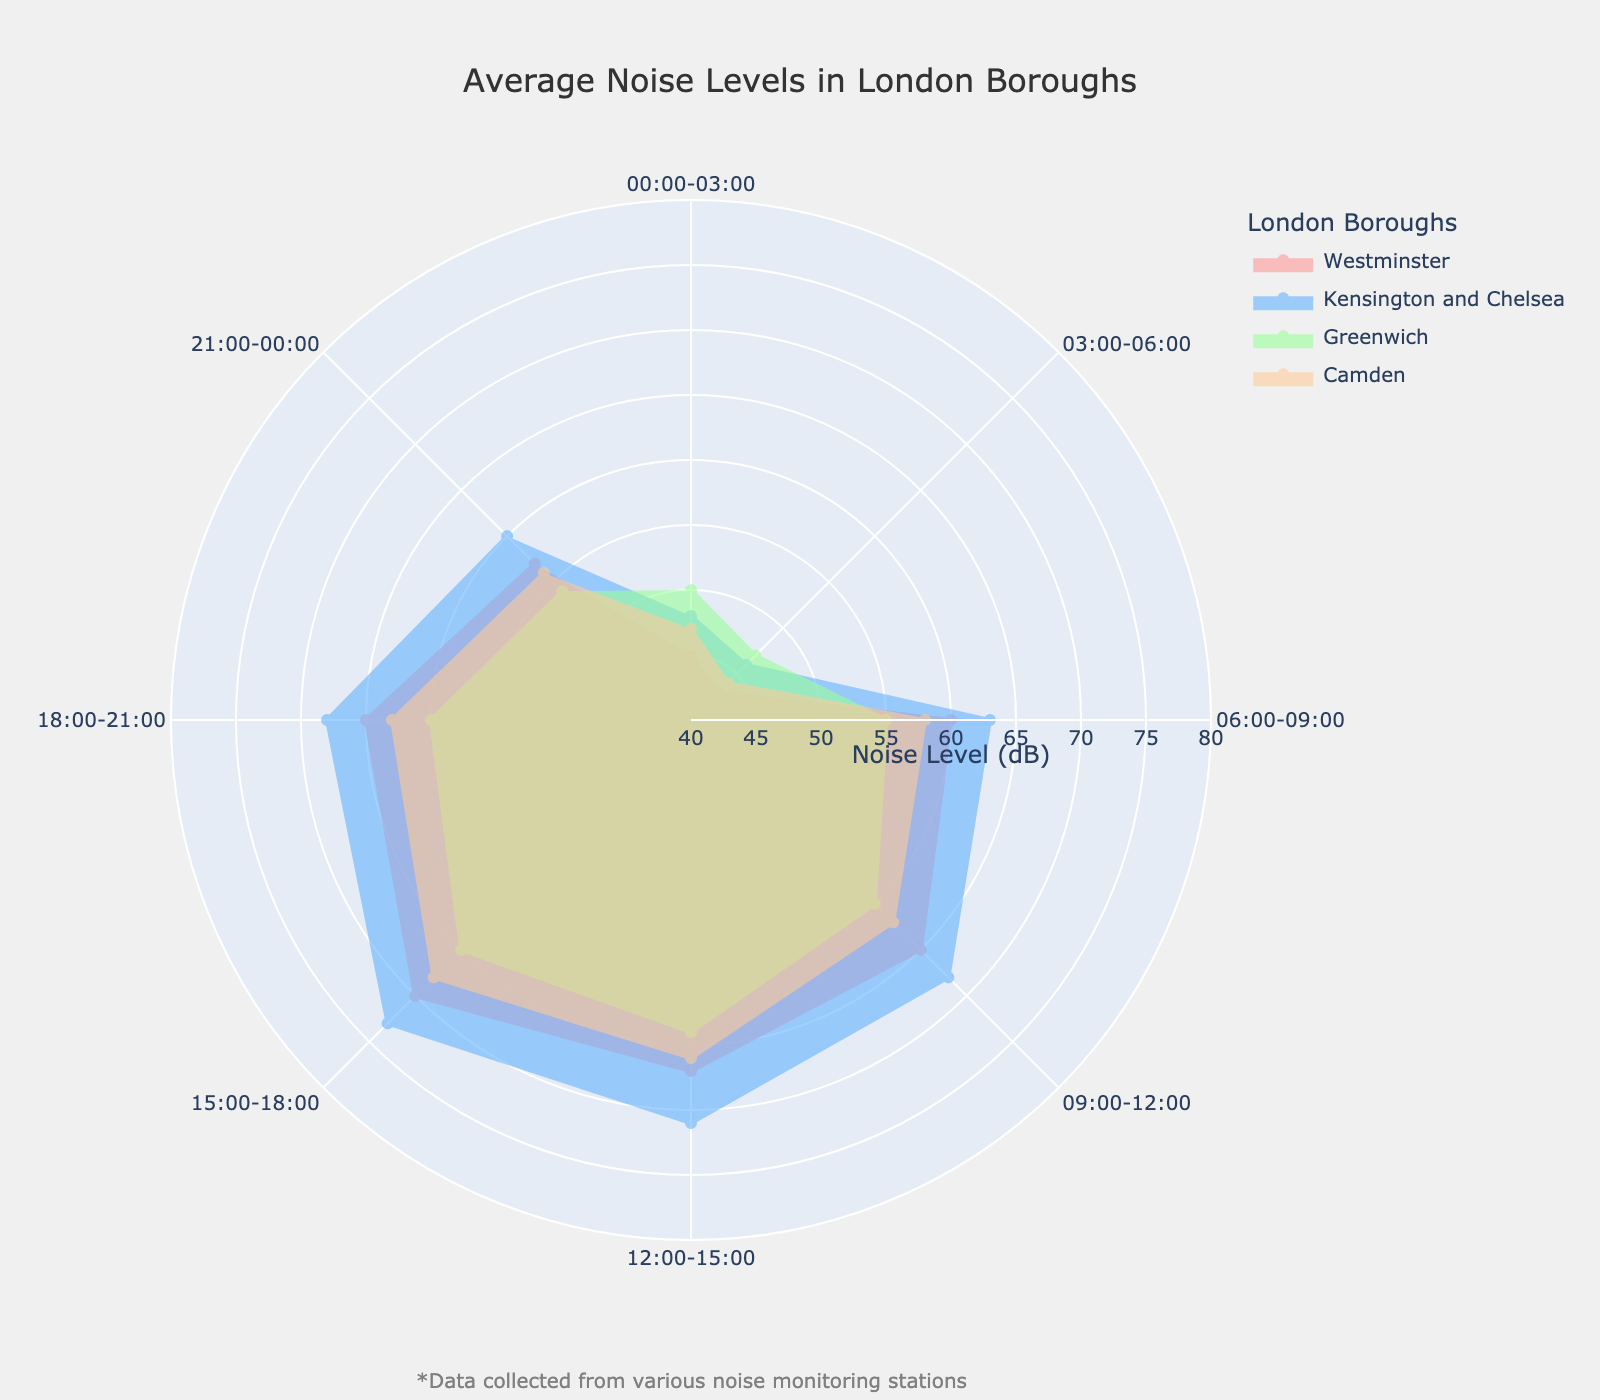what is the average noise level in Camden between 06:00 to 09:00? The figure shows the noise levels for Camden during different times. Look at the value corresponding to "06:00-09:00" under Camden, which is 58 dB.
Answer: 58 dB Which borough has the highest noise level during the 15:00-18:00 time period? The figure shows the noise levels for each borough during the different time periods. Look at the values corresponding to "15:00-18:00" for each borough: Westminster (70 dB), Kensington and Chelsea (73 dB), Greenwich (65 dB), and Camden (68 dB). Kensington and Chelsea have the highest value.
Answer: Kensington and Chelsea What is the difference in noise levels in Greenwich between 00:00-03:00 and 03:00-06:00? Look at the noise levels for Greenwich at "00:00-03:00" which is 50 dB and "03:00-06:00" which is 47 dB. The difference is 50 - 47 = 3 dB.
Answer: 3 dB During which time period does Westminster have the lowest noise level? Look at the noise levels for Westminster during different times. The values are: "00:00-03:00" (45 dB), "03:00-06:00" (43 dB), "06:00-09:00" (60 dB), "09:00-12:00" (65 dB), "12:00-15:00" (67 dB), "15:00-18:00" (70 dB), "18:00-21:00" (65 dB), and "21:00-00:00" (57 dB). The lowest value is at "03:00-06:00".
Answer: 03:00-06:00 What is the range of noise levels in Kensington and Chelsea throughout the day? Look at the noise levels for Kensington and Chelsea at different times: 48 dB (00:00-03:00), 46 dB (03:00-06:00), 63 dB (06:00-09:00), 68 dB (09:00-12:00), 71 dB (12:00-15:00), 73 dB (15:00-18:00), 68 dB (18:00-21:00), 60 dB (21:00-00:00). The range is the difference between the maximum and minimum values: 73 - 46 = 27 dB.
Answer: 27 dB 